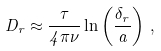<formula> <loc_0><loc_0><loc_500><loc_500>D _ { r } \approx \frac { \tau } { 4 \pi \nu } \ln \left ( \frac { \delta _ { r } } { a } \right ) \, ,</formula> 